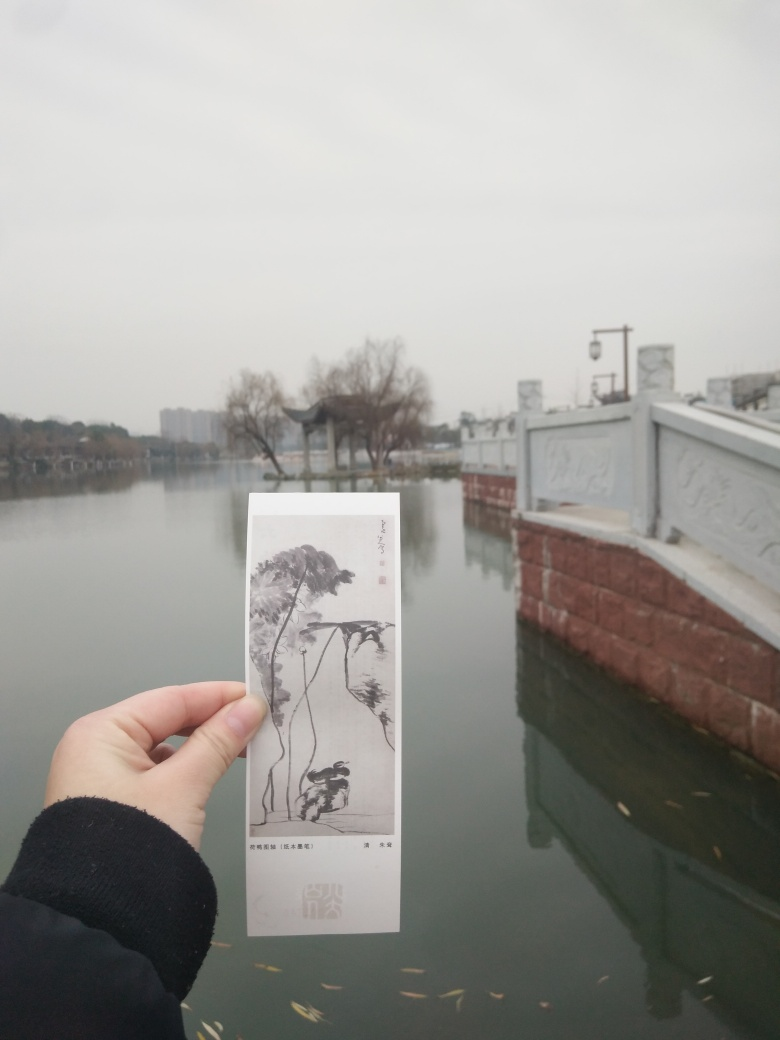What might be the story behind the person holding the bookmark? It's speculative, but the person holding the bookmark might be an admirer of art and nature who is visiting this tranquil location to find inspiration or solace. The act of contrasting the painted scene on the bookmark with the actual environment could represent a search for beauty in both man-made and natural forms. 